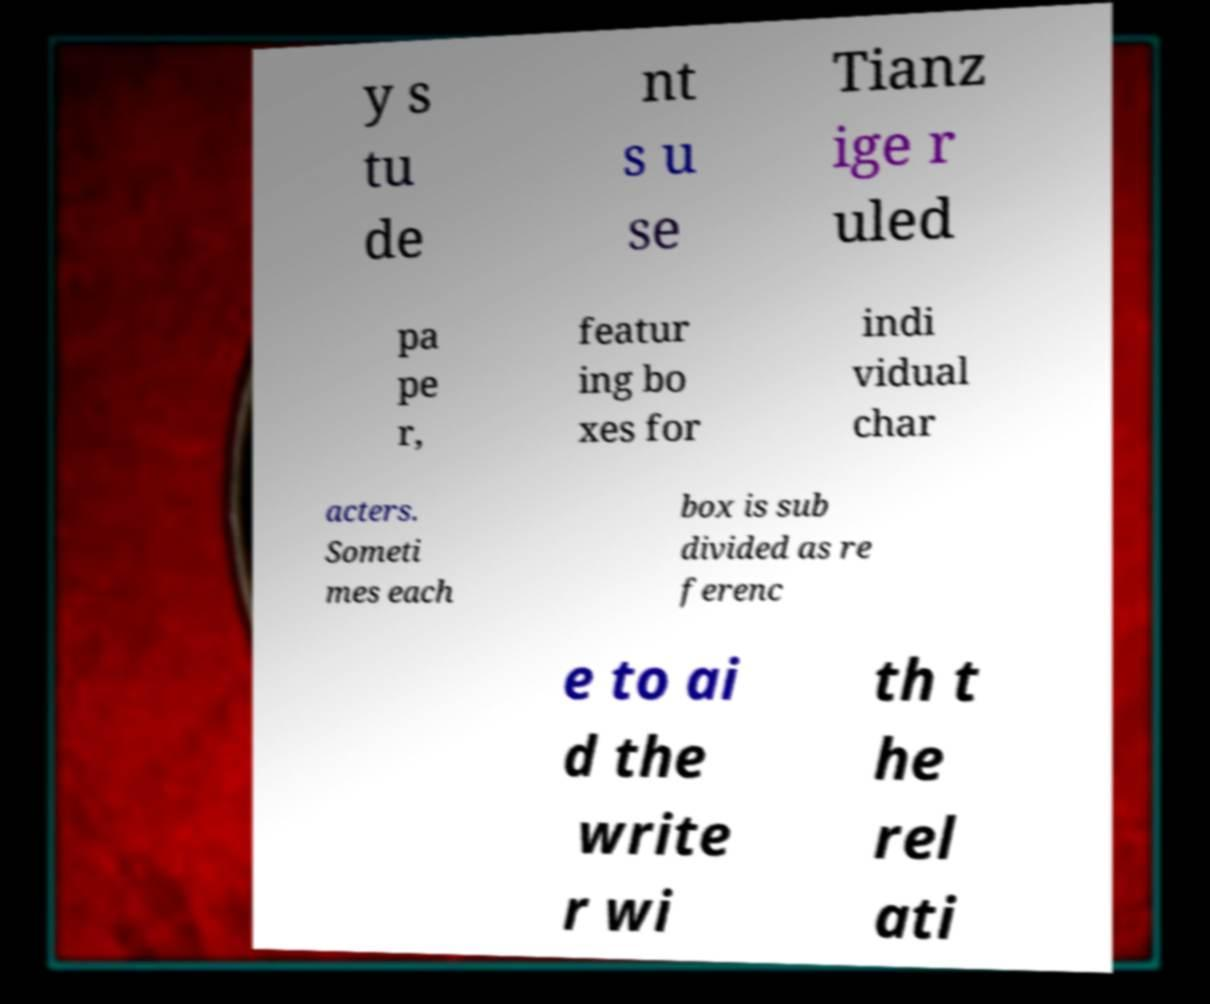Can you accurately transcribe the text from the provided image for me? y s tu de nt s u se Tianz ige r uled pa pe r, featur ing bo xes for indi vidual char acters. Someti mes each box is sub divided as re ferenc e to ai d the write r wi th t he rel ati 